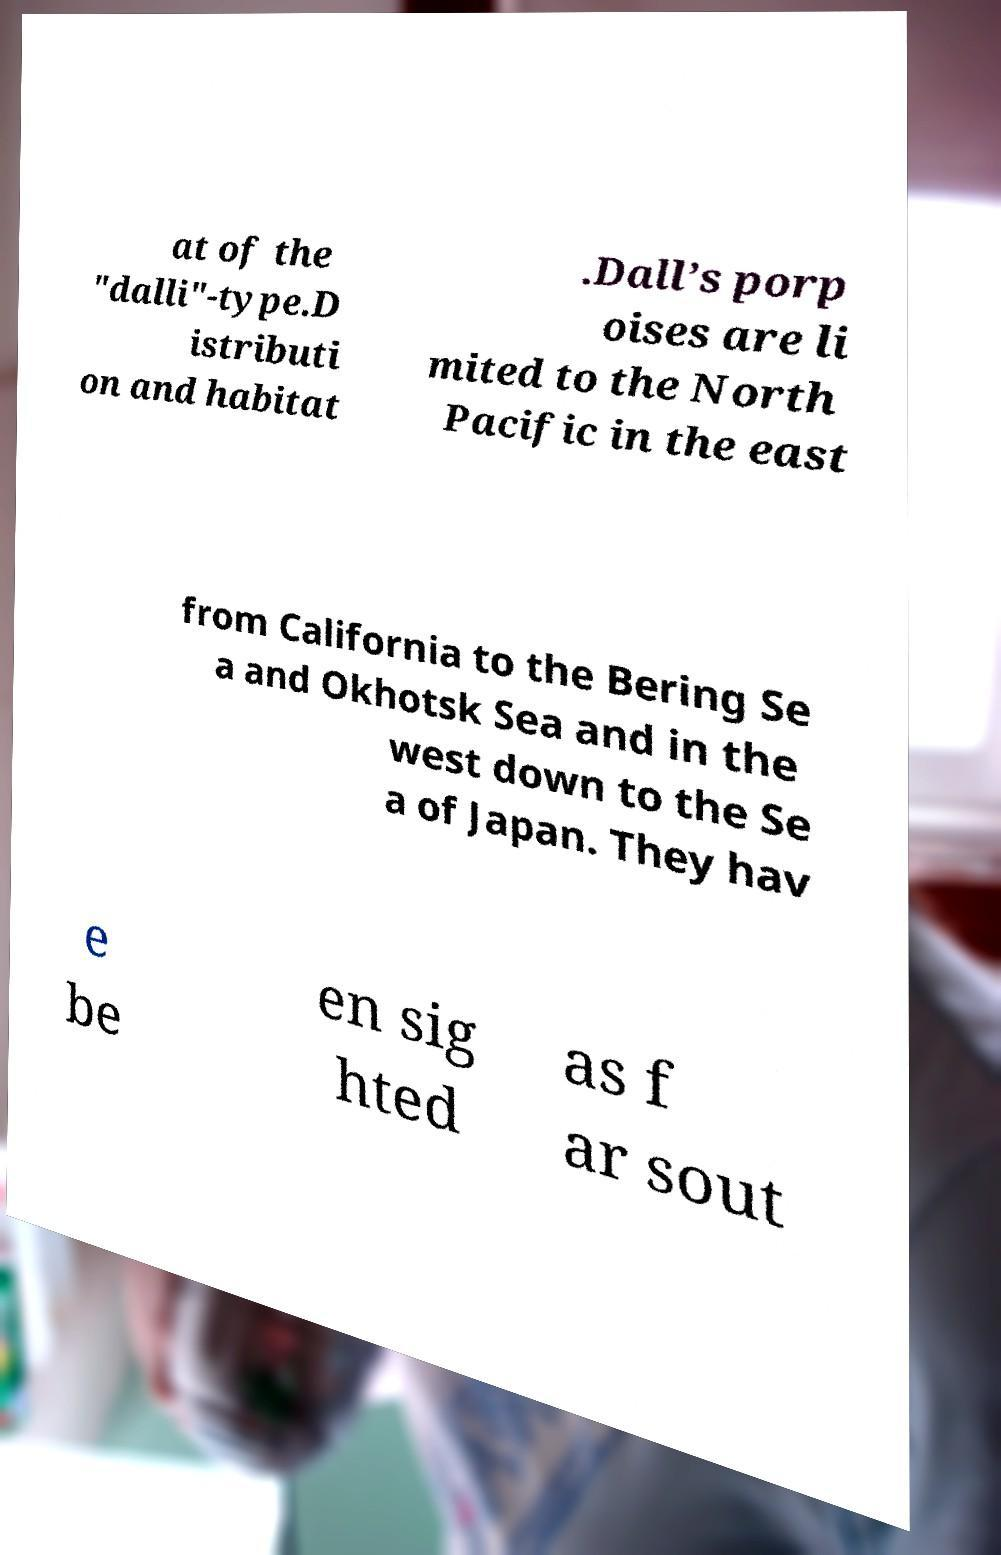For documentation purposes, I need the text within this image transcribed. Could you provide that? at of the "dalli"-type.D istributi on and habitat .Dall’s porp oises are li mited to the North Pacific in the east from California to the Bering Se a and Okhotsk Sea and in the west down to the Se a of Japan. They hav e be en sig hted as f ar sout 